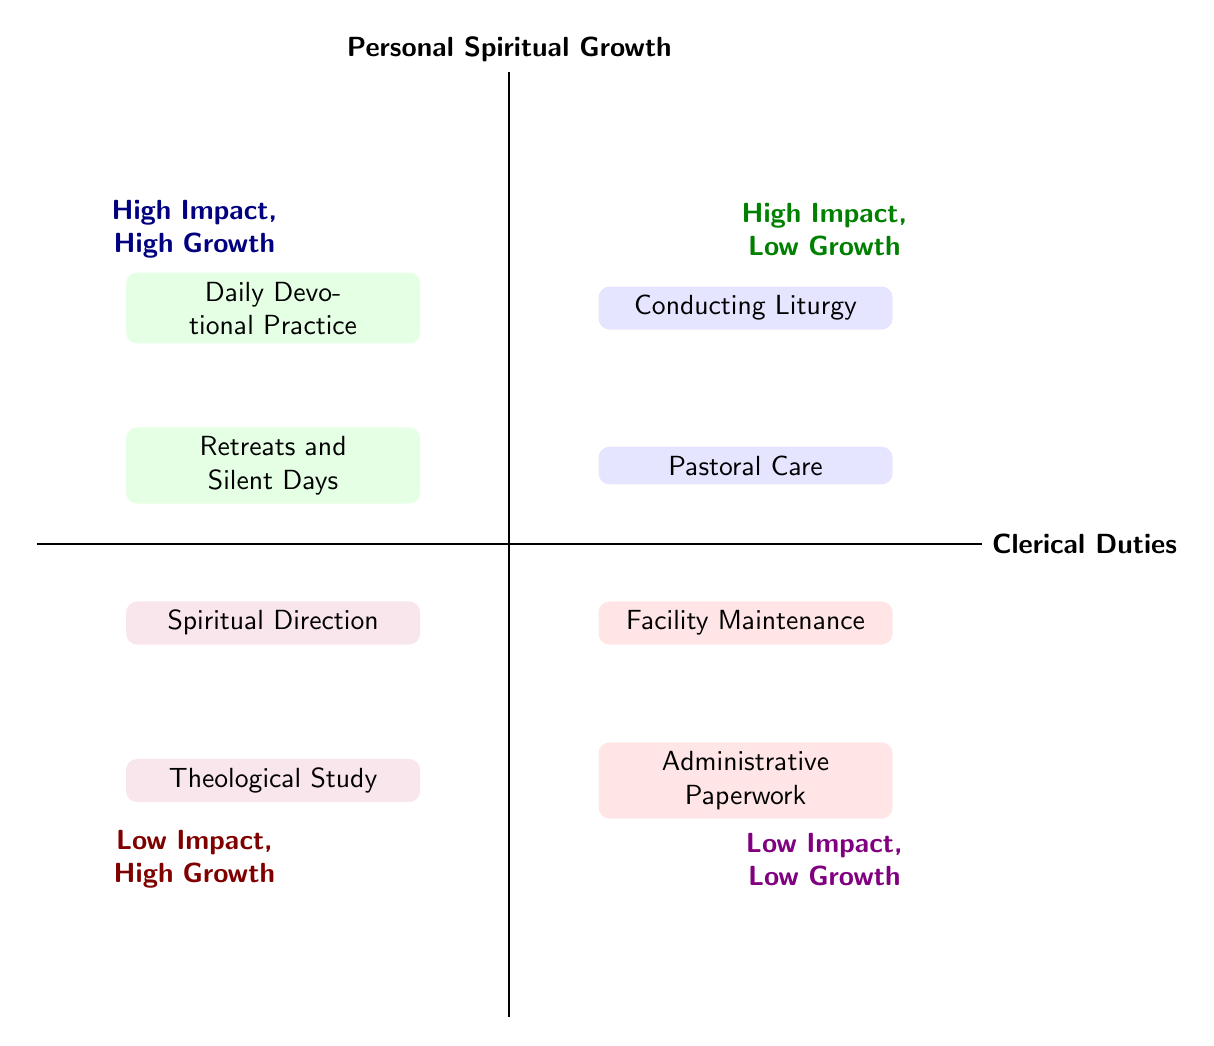What activities are listed in the "High Impact, High Growth" quadrant? The "High Impact, High Growth" quadrant lists "Daily Devotional Practice" and "Retreats and Silent Days." These are the only activities mentioned in that specific quadrant.
Answer: Daily Devotional Practice, Retreats and Silent Days Which activity is categorized as "Low Impact, High Growth"? In the "Low Impact, High Growth" quadrant, the activities are "Theological Study" and "Spiritual Direction." The question involves identifying one of the activities in that category.
Answer: Theological Study, Spiritual Direction How many activities are listed in the "High Impact" quadrant? There are a total of four activities in the "High Impact" category: two under "High Impact, High Growth" (which are Daily Devotional Practice and Retreats and Silent Days) and two under "High Impact, Low Growth" (which are Conducting Liturgy and Pastoral Care). So, the overall count is four.
Answer: 4 Which quadrant contains "Administrative Paperwork"? "Administrative Paperwork" is found in the "High Impact, Low Growth" quadrant, which is dedicated to clerical duties that have a lower personal spiritual growth aspect.
Answer: High Impact, Low Growth Which quadrant has the most significant personal spiritual growth activities? The quadrant that shows the most significant personal spiritual growth activities is "High Impact, High Growth." This quadrant includes activities that profoundly influence personal spiritual growth, such as those related to devotion.
Answer: High Impact, High Growth What is the relationship between "Pastoral Care" and "Facility Maintenance"? "Pastoral Care" is categorized as a "High Impact, Low Growth" clerical duty, while "Facility Maintenance" falls under "Low Impact, Low Growth." They occupy different quadrants concerning their impact on the church and personal growth.
Answer: Different quadrants How many activities are classified under "Clerical Duties"? There are a total of four activities listed under "Clerical Duties": "Conducting Liturgy" and "Pastoral Care" in the High Impact categories, and "Administrative Paperwork" and "Facility Maintenance" in the Low Impact categories, totaling four activities.
Answer: 4 Which quadrant has "Conducting Liturgy"? "Conducting Liturgy" is located in the "High Impact, Low Growth" quadrant, emphasizing its role as an essential clerical duty with contextual impact but comparatively less personal spiritual growth.
Answer: High Impact, Low Growth Which activity has the least personal spiritual growth impact? The activity with the least personal spiritual growth impact is classified as "Low Impact, Low Growth," which includes both "Administrative Paperwork" and "Facility Maintenance." Both are equally categorized under this classification.
Answer: Administrative Paperwork, Facility Maintenance 